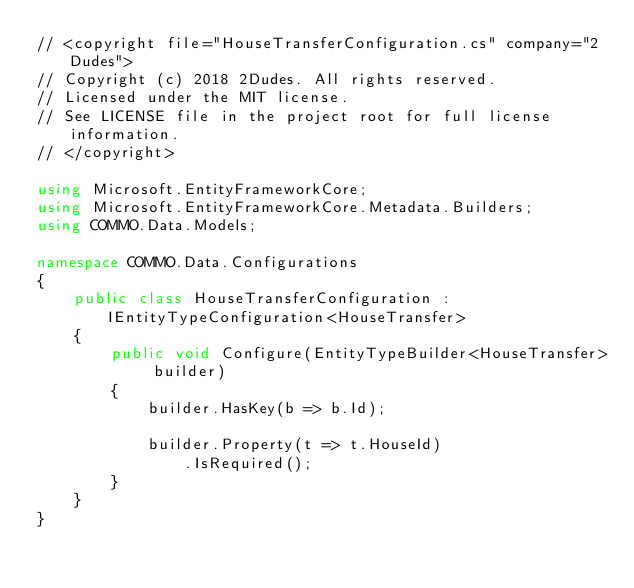Convert code to text. <code><loc_0><loc_0><loc_500><loc_500><_C#_>// <copyright file="HouseTransferConfiguration.cs" company="2Dudes">
// Copyright (c) 2018 2Dudes. All rights reserved.
// Licensed under the MIT license.
// See LICENSE file in the project root for full license information.
// </copyright>

using Microsoft.EntityFrameworkCore;
using Microsoft.EntityFrameworkCore.Metadata.Builders;
using COMMO.Data.Models;

namespace COMMO.Data.Configurations
{
    public class HouseTransferConfiguration : IEntityTypeConfiguration<HouseTransfer>
    {
        public void Configure(EntityTypeBuilder<HouseTransfer> builder)
        {
            builder.HasKey(b => b.Id);

            builder.Property(t => t.HouseId)
                .IsRequired();
        }
    }
}
</code> 